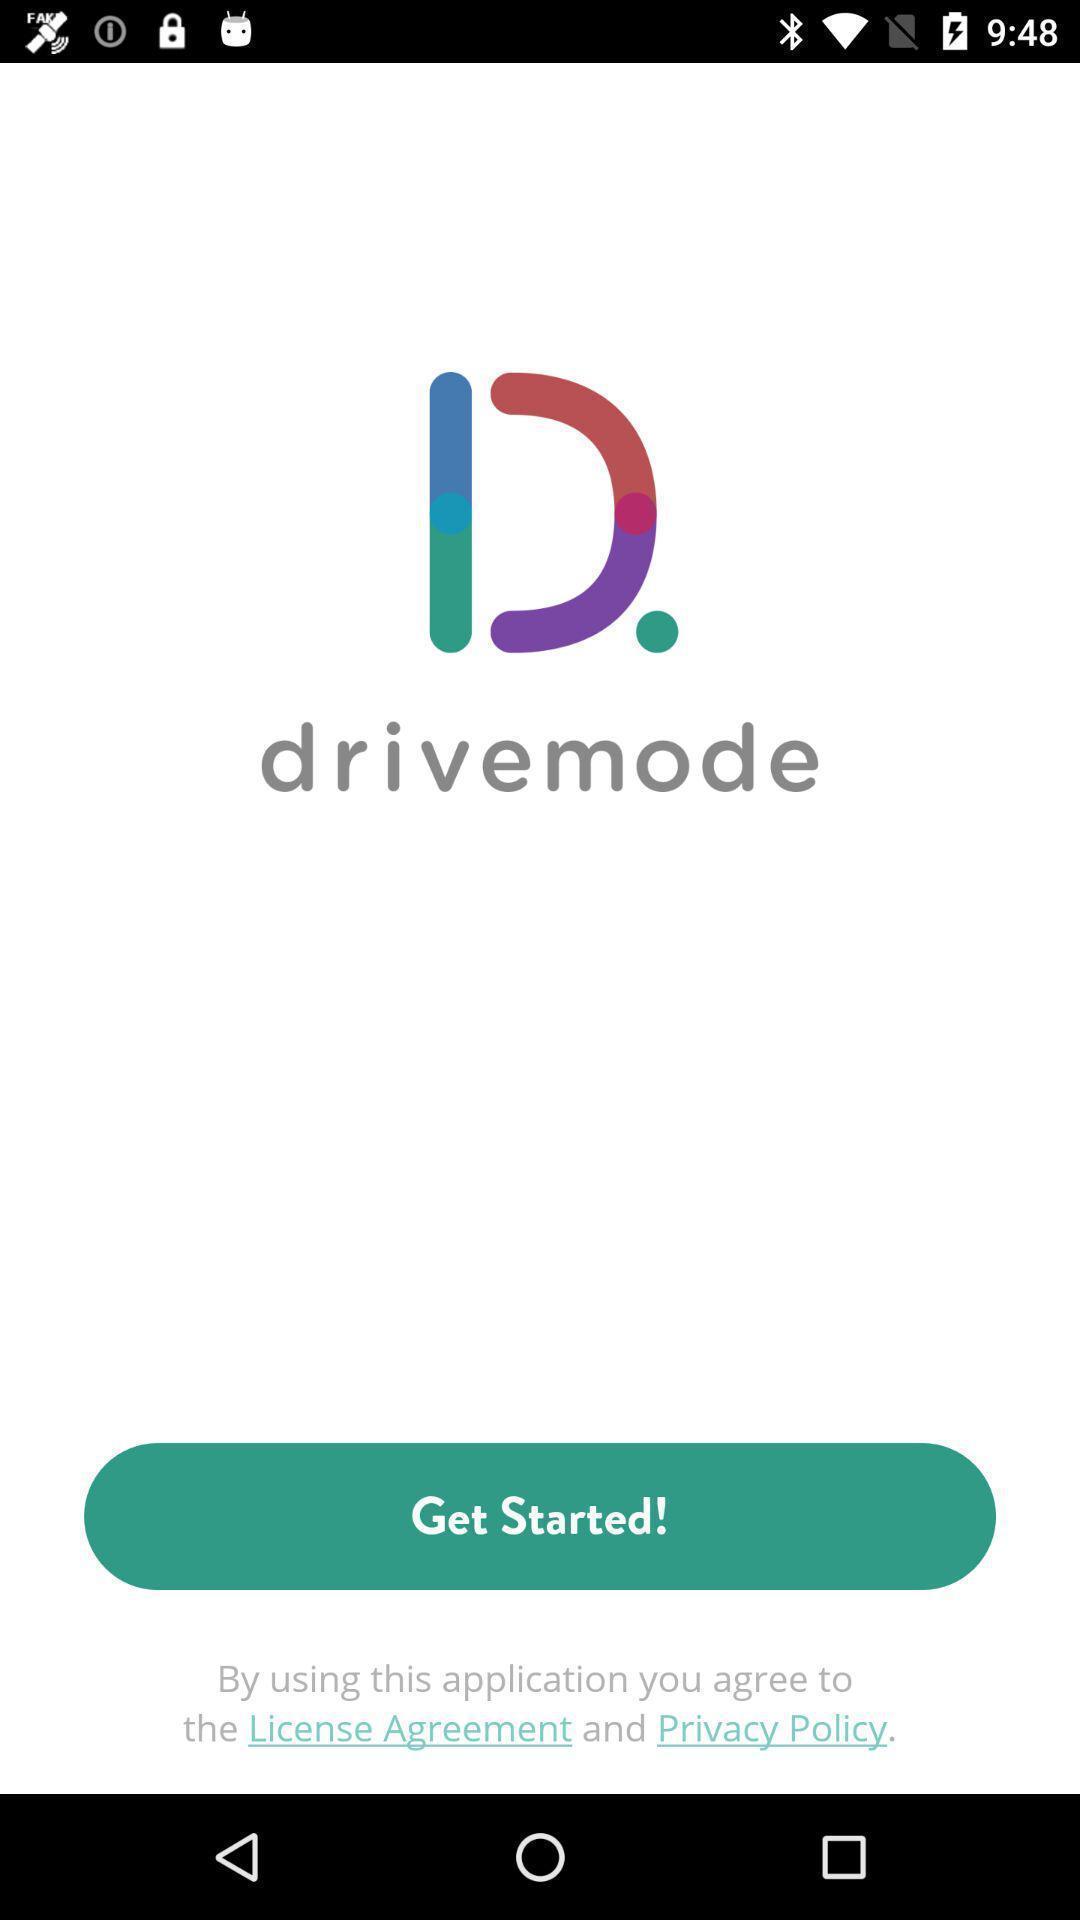Give me a narrative description of this picture. Welcome page. 